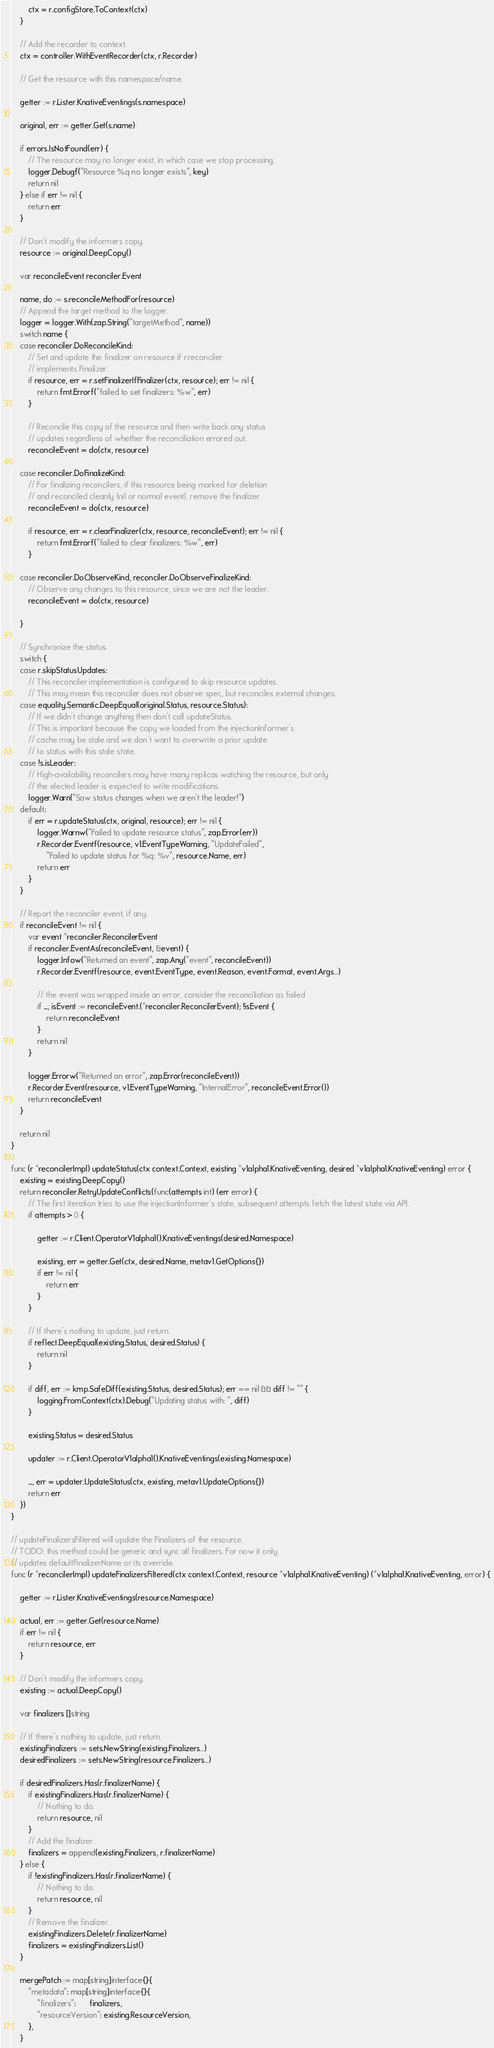Convert code to text. <code><loc_0><loc_0><loc_500><loc_500><_Go_>		ctx = r.configStore.ToContext(ctx)
	}

	// Add the recorder to context.
	ctx = controller.WithEventRecorder(ctx, r.Recorder)

	// Get the resource with this namespace/name.

	getter := r.Lister.KnativeEventings(s.namespace)

	original, err := getter.Get(s.name)

	if errors.IsNotFound(err) {
		// The resource may no longer exist, in which case we stop processing.
		logger.Debugf("Resource %q no longer exists", key)
		return nil
	} else if err != nil {
		return err
	}

	// Don't modify the informers copy.
	resource := original.DeepCopy()

	var reconcileEvent reconciler.Event

	name, do := s.reconcileMethodFor(resource)
	// Append the target method to the logger.
	logger = logger.With(zap.String("targetMethod", name))
	switch name {
	case reconciler.DoReconcileKind:
		// Set and update the finalizer on resource if r.reconciler
		// implements Finalizer.
		if resource, err = r.setFinalizerIfFinalizer(ctx, resource); err != nil {
			return fmt.Errorf("failed to set finalizers: %w", err)
		}

		// Reconcile this copy of the resource and then write back any status
		// updates regardless of whether the reconciliation errored out.
		reconcileEvent = do(ctx, resource)

	case reconciler.DoFinalizeKind:
		// For finalizing reconcilers, if this resource being marked for deletion
		// and reconciled cleanly (nil or normal event), remove the finalizer.
		reconcileEvent = do(ctx, resource)

		if resource, err = r.clearFinalizer(ctx, resource, reconcileEvent); err != nil {
			return fmt.Errorf("failed to clear finalizers: %w", err)
		}

	case reconciler.DoObserveKind, reconciler.DoObserveFinalizeKind:
		// Observe any changes to this resource, since we are not the leader.
		reconcileEvent = do(ctx, resource)

	}

	// Synchronize the status.
	switch {
	case r.skipStatusUpdates:
		// This reconciler implementation is configured to skip resource updates.
		// This may mean this reconciler does not observe spec, but reconciles external changes.
	case equality.Semantic.DeepEqual(original.Status, resource.Status):
		// If we didn't change anything then don't call updateStatus.
		// This is important because the copy we loaded from the injectionInformer's
		// cache may be stale and we don't want to overwrite a prior update
		// to status with this stale state.
	case !s.isLeader:
		// High-availability reconcilers may have many replicas watching the resource, but only
		// the elected leader is expected to write modifications.
		logger.Warn("Saw status changes when we aren't the leader!")
	default:
		if err = r.updateStatus(ctx, original, resource); err != nil {
			logger.Warnw("Failed to update resource status", zap.Error(err))
			r.Recorder.Eventf(resource, v1.EventTypeWarning, "UpdateFailed",
				"Failed to update status for %q: %v", resource.Name, err)
			return err
		}
	}

	// Report the reconciler event, if any.
	if reconcileEvent != nil {
		var event *reconciler.ReconcilerEvent
		if reconciler.EventAs(reconcileEvent, &event) {
			logger.Infow("Returned an event", zap.Any("event", reconcileEvent))
			r.Recorder.Eventf(resource, event.EventType, event.Reason, event.Format, event.Args...)

			// the event was wrapped inside an error, consider the reconciliation as failed
			if _, isEvent := reconcileEvent.(*reconciler.ReconcilerEvent); !isEvent {
				return reconcileEvent
			}
			return nil
		}

		logger.Errorw("Returned an error", zap.Error(reconcileEvent))
		r.Recorder.Event(resource, v1.EventTypeWarning, "InternalError", reconcileEvent.Error())
		return reconcileEvent
	}

	return nil
}

func (r *reconcilerImpl) updateStatus(ctx context.Context, existing *v1alpha1.KnativeEventing, desired *v1alpha1.KnativeEventing) error {
	existing = existing.DeepCopy()
	return reconciler.RetryUpdateConflicts(func(attempts int) (err error) {
		// The first iteration tries to use the injectionInformer's state, subsequent attempts fetch the latest state via API.
		if attempts > 0 {

			getter := r.Client.OperatorV1alpha1().KnativeEventings(desired.Namespace)

			existing, err = getter.Get(ctx, desired.Name, metav1.GetOptions{})
			if err != nil {
				return err
			}
		}

		// If there's nothing to update, just return.
		if reflect.DeepEqual(existing.Status, desired.Status) {
			return nil
		}

		if diff, err := kmp.SafeDiff(existing.Status, desired.Status); err == nil && diff != "" {
			logging.FromContext(ctx).Debug("Updating status with: ", diff)
		}

		existing.Status = desired.Status

		updater := r.Client.OperatorV1alpha1().KnativeEventings(existing.Namespace)

		_, err = updater.UpdateStatus(ctx, existing, metav1.UpdateOptions{})
		return err
	})
}

// updateFinalizersFiltered will update the Finalizers of the resource.
// TODO: this method could be generic and sync all finalizers. For now it only
// updates defaultFinalizerName or its override.
func (r *reconcilerImpl) updateFinalizersFiltered(ctx context.Context, resource *v1alpha1.KnativeEventing) (*v1alpha1.KnativeEventing, error) {

	getter := r.Lister.KnativeEventings(resource.Namespace)

	actual, err := getter.Get(resource.Name)
	if err != nil {
		return resource, err
	}

	// Don't modify the informers copy.
	existing := actual.DeepCopy()

	var finalizers []string

	// If there's nothing to update, just return.
	existingFinalizers := sets.NewString(existing.Finalizers...)
	desiredFinalizers := sets.NewString(resource.Finalizers...)

	if desiredFinalizers.Has(r.finalizerName) {
		if existingFinalizers.Has(r.finalizerName) {
			// Nothing to do.
			return resource, nil
		}
		// Add the finalizer.
		finalizers = append(existing.Finalizers, r.finalizerName)
	} else {
		if !existingFinalizers.Has(r.finalizerName) {
			// Nothing to do.
			return resource, nil
		}
		// Remove the finalizer.
		existingFinalizers.Delete(r.finalizerName)
		finalizers = existingFinalizers.List()
	}

	mergePatch := map[string]interface{}{
		"metadata": map[string]interface{}{
			"finalizers":      finalizers,
			"resourceVersion": existing.ResourceVersion,
		},
	}
</code> 